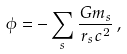<formula> <loc_0><loc_0><loc_500><loc_500>\phi = - \sum _ { s } \frac { G m _ { s } } { r _ { s } c ^ { 2 } } \, ,</formula> 